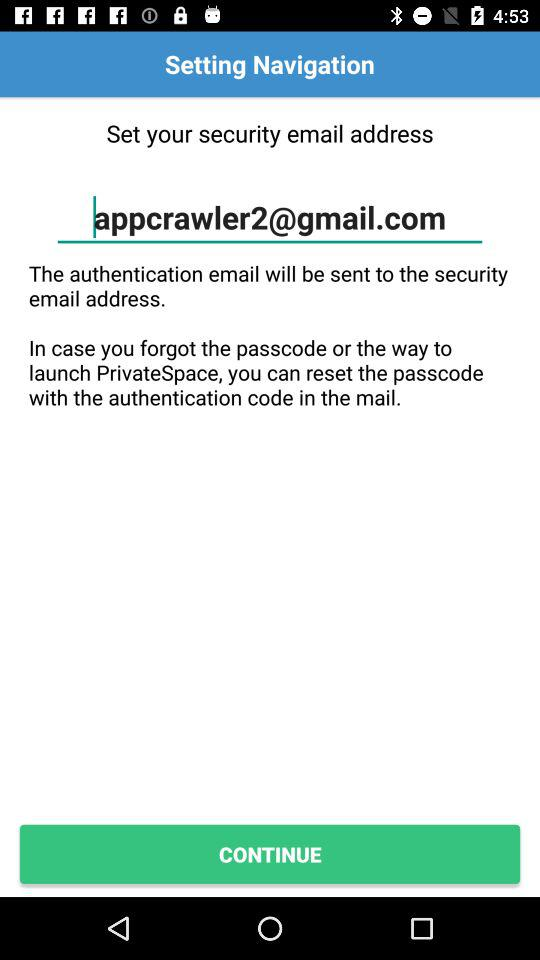Which email will be sent to the security email address? To the security email address, the authentication email will be sent. 